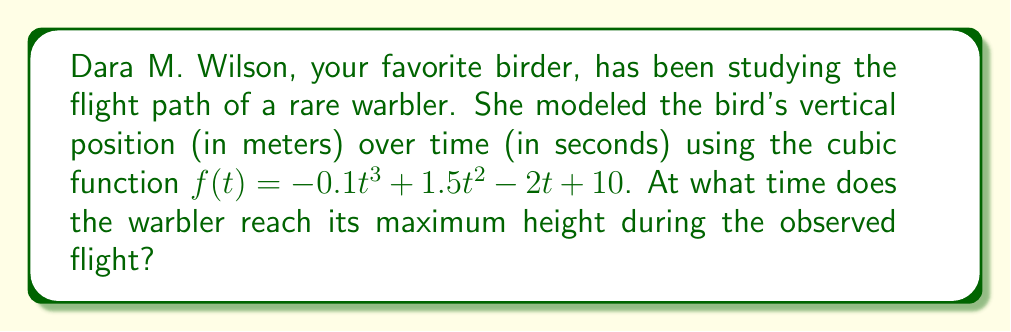Could you help me with this problem? To find the maximum height of the warbler's flight, we need to determine the time at which the derivative of the function $f(t)$ equals zero. This will give us the critical point where the bird's height is at its peak.

1) First, let's find the derivative of $f(t)$:
   $$f'(t) = -0.3t^2 + 3t - 2$$

2) Now, we set $f'(t) = 0$ and solve for $t$:
   $$-0.3t^2 + 3t - 2 = 0$$

3) This is a quadratic equation. We can solve it using the quadratic formula:
   $$t = \frac{-b \pm \sqrt{b^2 - 4ac}}{2a}$$
   where $a = -0.3$, $b = 3$, and $c = -2$

4) Substituting these values:
   $$t = \frac{-3 \pm \sqrt{3^2 - 4(-0.3)(-2)}}{2(-0.3)}$$
   $$= \frac{-3 \pm \sqrt{9 - 2.4}}{-0.6}$$
   $$= \frac{-3 \pm \sqrt{6.6}}{-0.6}$$

5) Simplifying:
   $$t = \frac{-3 \pm 2.569}{-0.6}$$

6) This gives us two solutions:
   $$t_1 = \frac{-3 + 2.569}{-0.6} \approx 0.718$$
   $$t_2 = \frac{-3 - 2.569}{-0.6} \approx 9.282$$

7) To determine which of these is the maximum (rather than the minimum), we can check the second derivative:
   $$f''(t) = -0.6t + 3$$
   
   At $t = 0.718$, $f''(0.718) \approx 2.569 > 0$, indicating a local minimum.
   At $t = 9.282$, $f''(9.282) \approx -2.569 < 0$, indicating a local maximum.

Therefore, the warbler reaches its maximum height at approximately 9.282 seconds.
Answer: The warbler reaches its maximum height at approximately 9.282 seconds. 